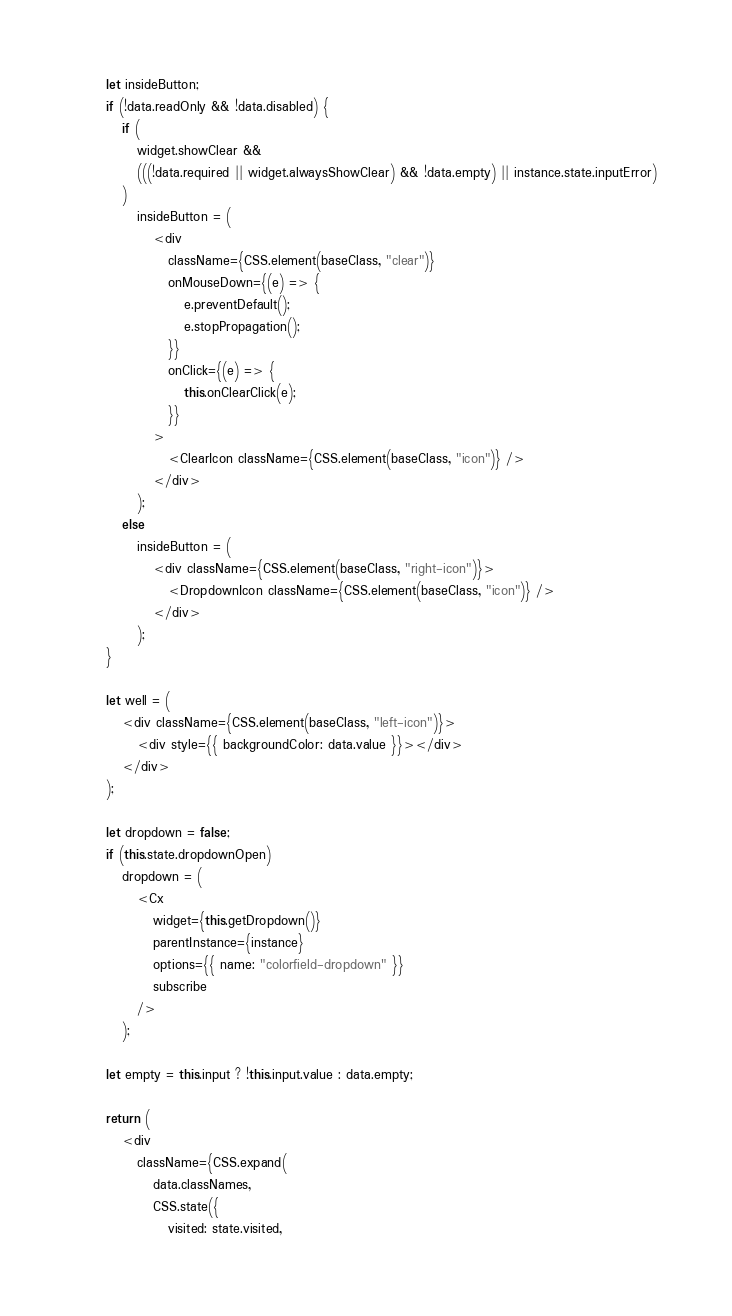<code> <loc_0><loc_0><loc_500><loc_500><_JavaScript_>      let insideButton;
      if (!data.readOnly && !data.disabled) {
         if (
            widget.showClear &&
            (((!data.required || widget.alwaysShowClear) && !data.empty) || instance.state.inputError)
         )
            insideButton = (
               <div
                  className={CSS.element(baseClass, "clear")}
                  onMouseDown={(e) => {
                     e.preventDefault();
                     e.stopPropagation();
                  }}
                  onClick={(e) => {
                     this.onClearClick(e);
                  }}
               >
                  <ClearIcon className={CSS.element(baseClass, "icon")} />
               </div>
            );
         else
            insideButton = (
               <div className={CSS.element(baseClass, "right-icon")}>
                  <DropdownIcon className={CSS.element(baseClass, "icon")} />
               </div>
            );
      }

      let well = (
         <div className={CSS.element(baseClass, "left-icon")}>
            <div style={{ backgroundColor: data.value }}></div>
         </div>
      );

      let dropdown = false;
      if (this.state.dropdownOpen)
         dropdown = (
            <Cx
               widget={this.getDropdown()}
               parentInstance={instance}
               options={{ name: "colorfield-dropdown" }}
               subscribe
            />
         );

      let empty = this.input ? !this.input.value : data.empty;

      return (
         <div
            className={CSS.expand(
               data.classNames,
               CSS.state({
                  visited: state.visited,</code> 